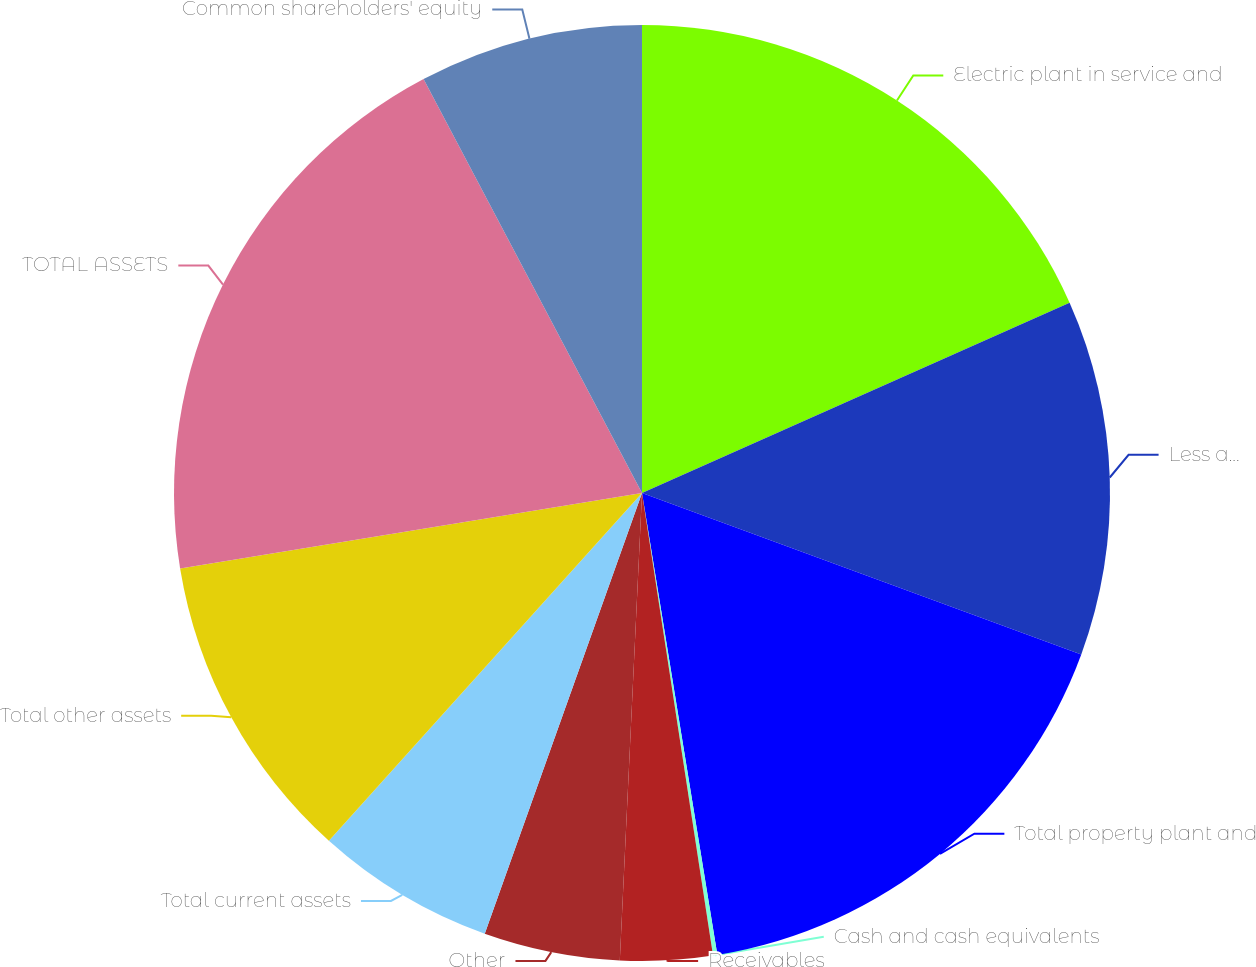<chart> <loc_0><loc_0><loc_500><loc_500><pie_chart><fcel>Electric plant in service and<fcel>Less accumulated depreciation<fcel>Total property plant and<fcel>Cash and cash equivalents<fcel>Receivables<fcel>Other<fcel>Total current assets<fcel>Total other assets<fcel>TOTAL ASSETS<fcel>Common shareholders' equity<nl><fcel>18.34%<fcel>12.27%<fcel>16.82%<fcel>0.15%<fcel>3.18%<fcel>4.7%<fcel>6.21%<fcel>10.76%<fcel>19.85%<fcel>7.73%<nl></chart> 